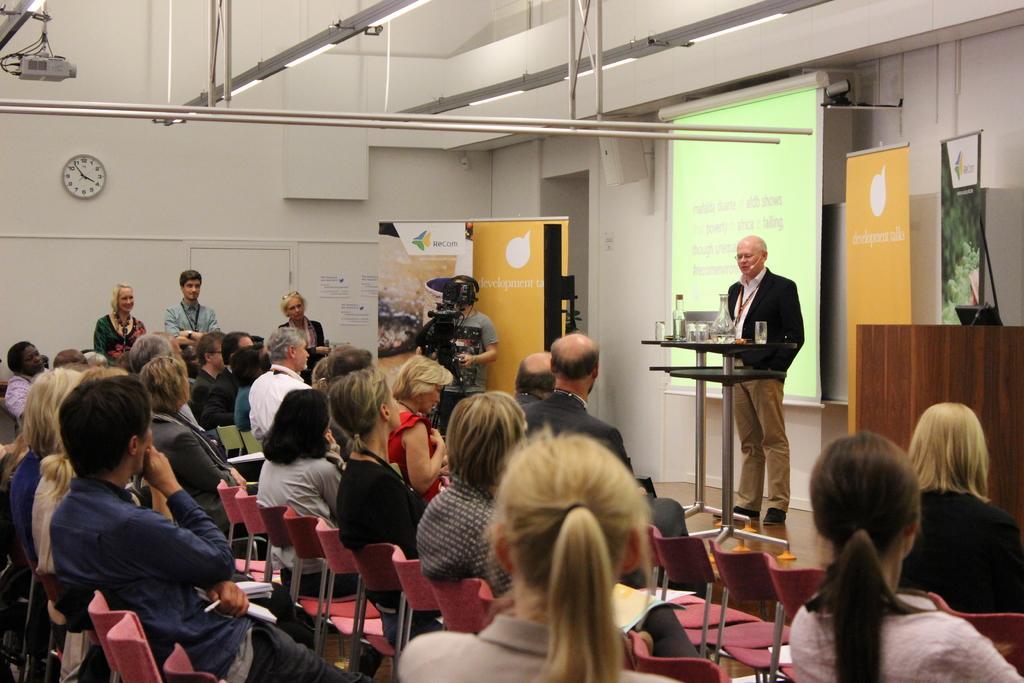Please provide a concise description of this image. At the top we can see lights and a projector. In the background we can see a clock, hoardings, screen. Here we can see a man standing on the platform near to a table and on the table we can see glasses and other objects. Here we can see people sitting on the chairs. Here we can see a man recording with a camera. We can see two women and a man standing. 